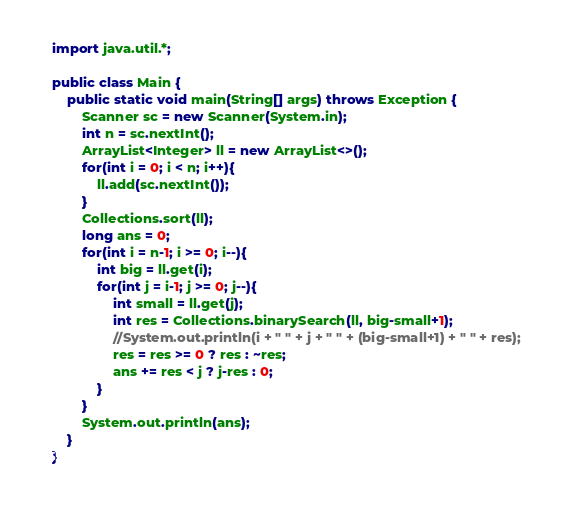<code> <loc_0><loc_0><loc_500><loc_500><_Java_>import java.util.*;

public class Main {
    public static void main(String[] args) throws Exception {
        Scanner sc = new Scanner(System.in);
        int n = sc.nextInt();
        ArrayList<Integer> ll = new ArrayList<>();
        for(int i = 0; i < n; i++){
            ll.add(sc.nextInt());
        }
        Collections.sort(ll);
        long ans = 0;
        for(int i = n-1; i >= 0; i--){
            int big = ll.get(i);
            for(int j = i-1; j >= 0; j--){
                int small = ll.get(j);
                int res = Collections.binarySearch(ll, big-small+1);
                //System.out.println(i + " " + j + " " + (big-small+1) + " " + res);
                res = res >= 0 ? res : ~res;
                ans += res < j ? j-res : 0;
            }
        }
        System.out.println(ans);
    }
}
</code> 